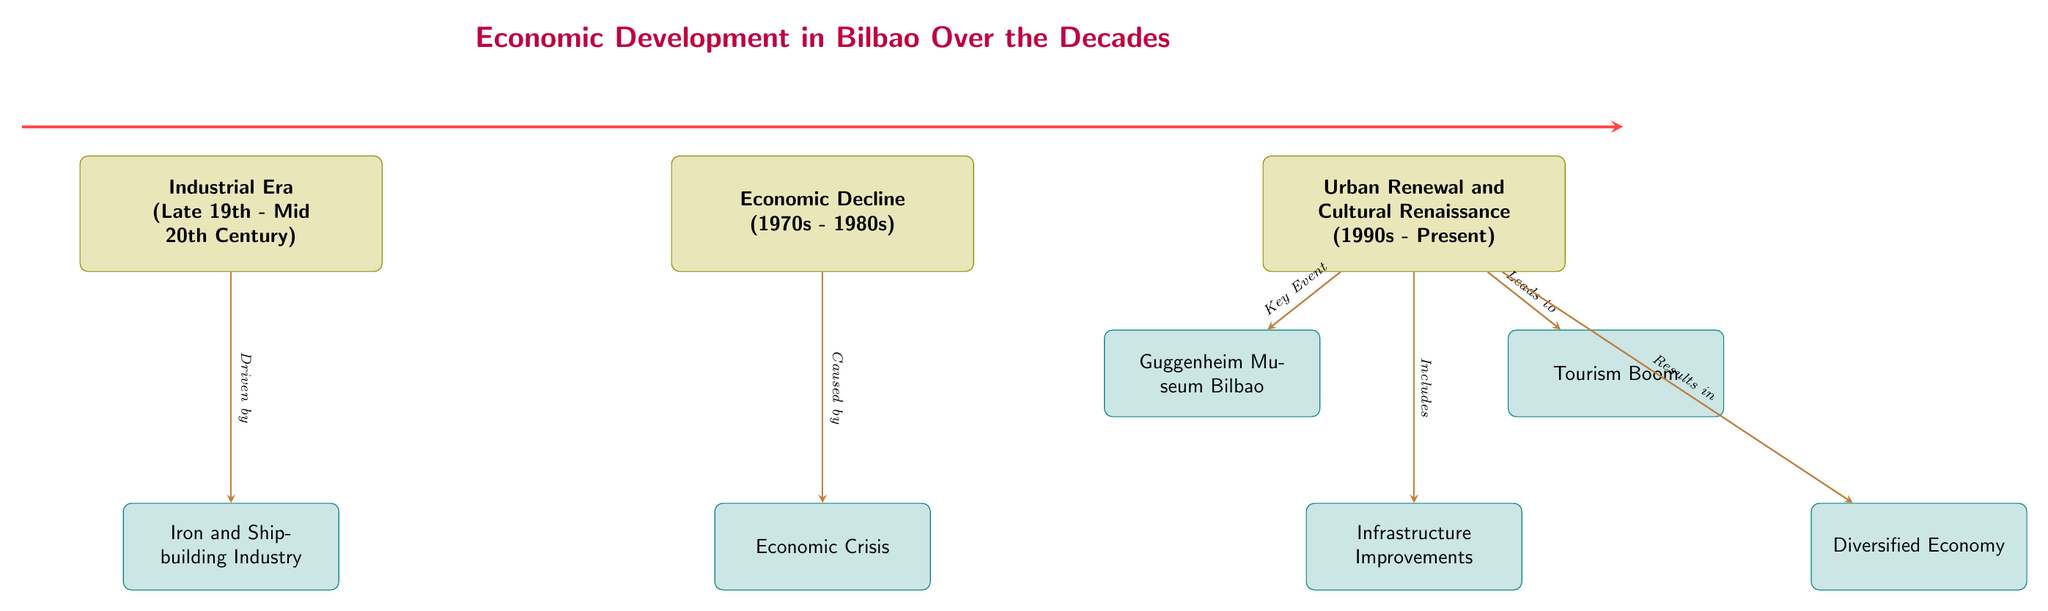What are the three main periods of economic development represented in the diagram? The diagram outlines three main periods: the Industrial Era, Economic Decline, and Urban Renewal and Cultural Renaissance.
Answer: Industrial Era, Economic Decline, Urban Renewal and Cultural Renaissance What industry was prominent during the Industrial Era in Bilbao? The diagram indicates that the Iron and Shipbuilding Industry was prominent during the Industrial Era as detailed in the sub-node below it.
Answer: Iron and Shipbuilding Industry What economic condition did Bilbao face in the 1970s and 1980s? The diagram states that the economic condition during the 1970s and 1980s was an Economic Crisis as shown in the corresponding box.
Answer: Economic Crisis Which significant cultural landmark is mentioned as part of the recent economic development in Bilbao? The diagram highlights the Guggenheim Museum Bilbao as the key cultural landmark that contributed to the Urban Renewal and Cultural Renaissance phase.
Answer: Guggenheim Museum Bilbao What is one consequence of the Urban Renewal and Cultural Renaissance according to the diagram? The diagram shows that one consequence of the Urban Renewal and Cultural Renaissance is the Tourism Boom, indicated by the relevant small box that leads from the main node.
Answer: Tourism Boom How many sub-nodes are connected to the main node of Urban Renewal and Cultural Renaissance? The diagram shows three sub-nodes branching from the main node of Urban Renewal and Cultural Renaissance: Guggenheim Museum Bilbao, Infrastructure Improvements, and Tourism Boom, indicating there are three connections.
Answer: Three What does the Economic Decline phase lead to in terms of economic development? In the diagram, the Economic Decline phase is followed by the Urban Renewal and Cultural Renaissance phase, indicating that the decline led to the need for renewal and cultural revival.
Answer: Urban Renewal and Cultural Renaissance Which aspect of recent economic development includes the Diversified Economy? According to the diagram, the aspect that includes the Diversified Economy is a direct result of the Urban Renewal and Cultural Renaissance, as shown in the smallbox connected to it.
Answer: Diversified Economy 